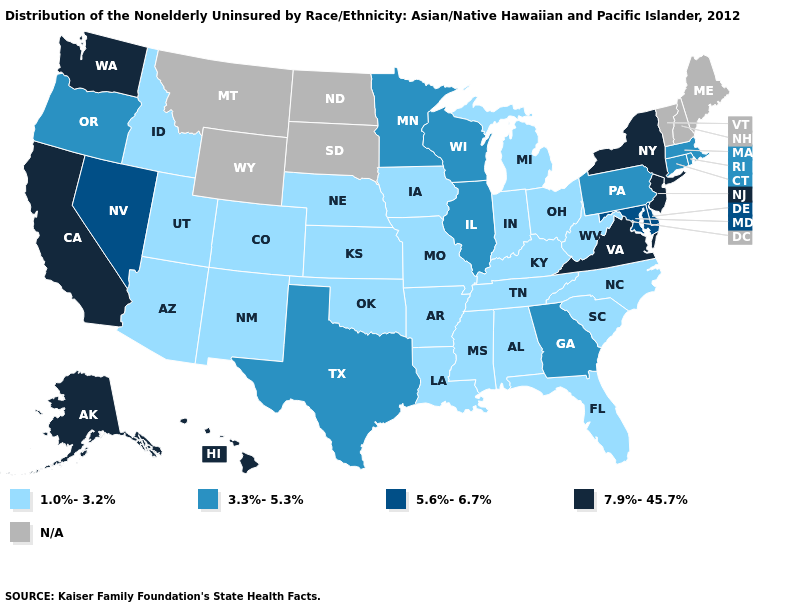Which states have the lowest value in the USA?
Answer briefly. Alabama, Arizona, Arkansas, Colorado, Florida, Idaho, Indiana, Iowa, Kansas, Kentucky, Louisiana, Michigan, Mississippi, Missouri, Nebraska, New Mexico, North Carolina, Ohio, Oklahoma, South Carolina, Tennessee, Utah, West Virginia. What is the value of Alabama?
Short answer required. 1.0%-3.2%. Which states have the highest value in the USA?
Concise answer only. Alaska, California, Hawaii, New Jersey, New York, Virginia, Washington. What is the highest value in the South ?
Answer briefly. 7.9%-45.7%. What is the value of New York?
Give a very brief answer. 7.9%-45.7%. What is the highest value in the USA?
Concise answer only. 7.9%-45.7%. Among the states that border Arizona , does Nevada have the highest value?
Write a very short answer. No. Which states have the lowest value in the USA?
Write a very short answer. Alabama, Arizona, Arkansas, Colorado, Florida, Idaho, Indiana, Iowa, Kansas, Kentucky, Louisiana, Michigan, Mississippi, Missouri, Nebraska, New Mexico, North Carolina, Ohio, Oklahoma, South Carolina, Tennessee, Utah, West Virginia. Does the map have missing data?
Answer briefly. Yes. Name the states that have a value in the range 1.0%-3.2%?
Short answer required. Alabama, Arizona, Arkansas, Colorado, Florida, Idaho, Indiana, Iowa, Kansas, Kentucky, Louisiana, Michigan, Mississippi, Missouri, Nebraska, New Mexico, North Carolina, Ohio, Oklahoma, South Carolina, Tennessee, Utah, West Virginia. Name the states that have a value in the range 7.9%-45.7%?
Quick response, please. Alaska, California, Hawaii, New Jersey, New York, Virginia, Washington. What is the lowest value in the Northeast?
Keep it brief. 3.3%-5.3%. What is the value of Iowa?
Answer briefly. 1.0%-3.2%. 